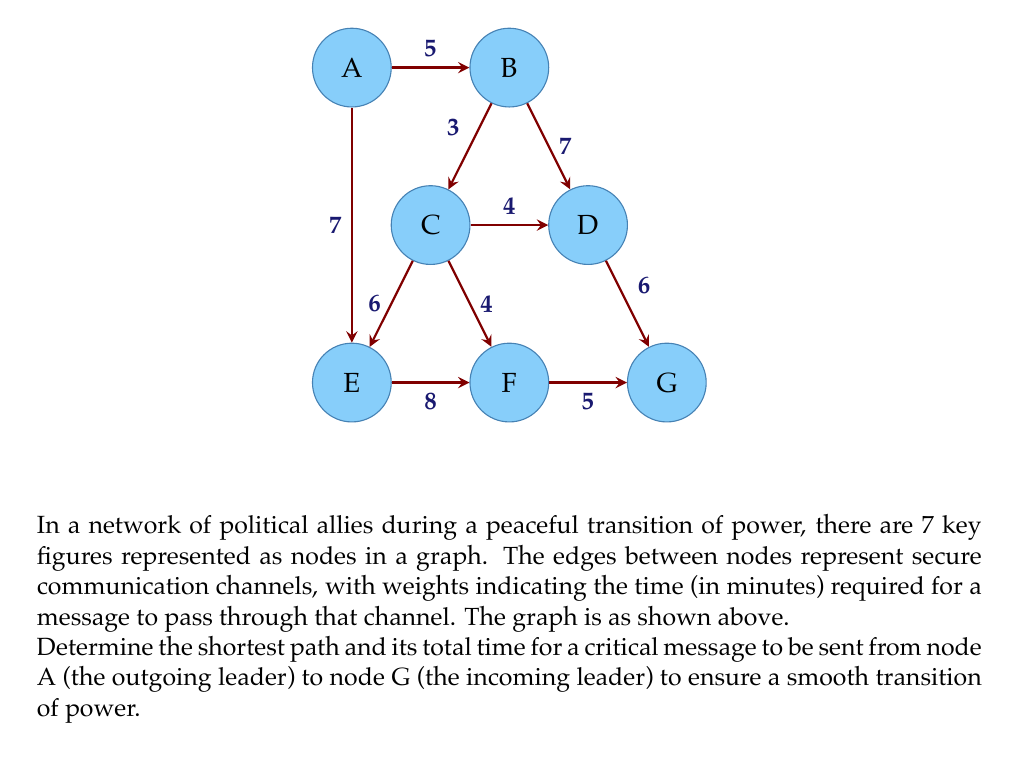Could you help me with this problem? To solve this problem, we can use Dijkstra's algorithm to find the shortest path in a weighted graph. Let's go through the process step-by-step:

1) Initialize:
   - Set distance to A as 0 and all other nodes as infinity.
   - Set all nodes as unvisited.
   - Set A as the current node.

2) For the current node, consider all unvisited neighbors and calculate their tentative distances.
   - From A: B(5), E(7)

3) Mark A as visited. B has the smallest tentative distance, so make B the current node.

4) From B:
   - To C: 5 + 3 = 8
   - To D: 5 + 7 = 12

5) Mark B as visited. C has the smallest tentative distance, so make C the current node.

6) From C:
   - To D: min(12, 8 + 4) = 12
   - To E: min(7, 8 + 6) = 7
   - To F: 8 + 4 = 12

7) Mark C as visited. E has the smallest tentative distance, so make E the current node.

8) From E:
   - To F: min(12, 7 + 8) = 15

9) Mark E as visited. D has the smallest tentative distance, so make D the current node.

10) From D:
    - To G: 12 + 6 = 18

11) Mark D as visited. F has the smallest tentative distance, so make F the current node.

12) From F:
    - To G: min(18, 15 + 5) = 18

13) Mark F as visited. G is the only unvisited node left, so make it the current node.

14) All nodes are visited. The algorithm is complete.

The shortest path from A to G is A → B → C → D → G with a total time of 18 minutes.
Answer: The shortest path is A → B → C → D → G, with a total time of 18 minutes. 